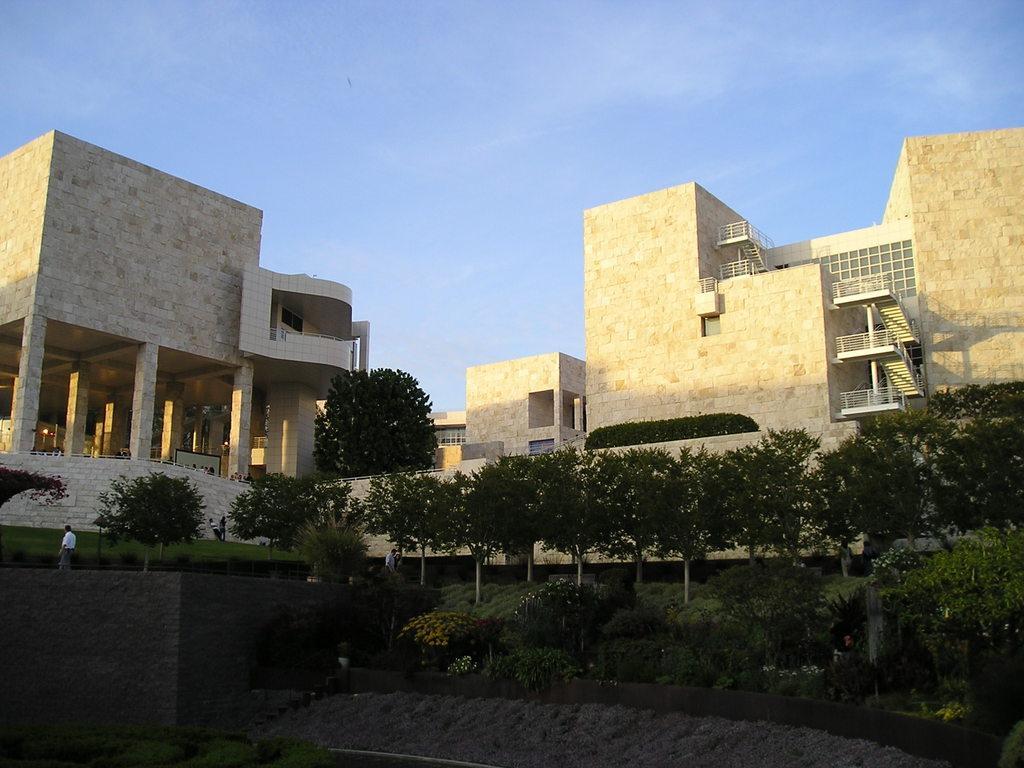Describe this image in one or two sentences. There are plants, a person and grassland in the foreground area of the image, there are buildings and the sky in the background. 